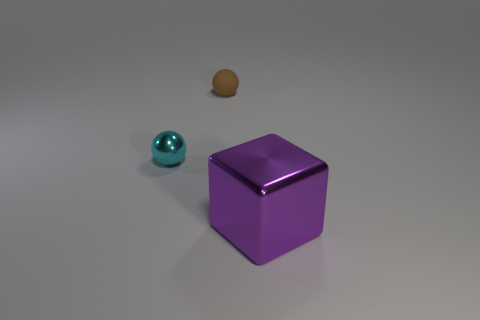Add 1 blocks. How many objects exist? 4 Subtract all blocks. How many objects are left? 2 Add 1 small metal objects. How many small metal objects are left? 2 Add 1 big yellow rubber objects. How many big yellow rubber objects exist? 1 Subtract 0 gray balls. How many objects are left? 3 Subtract all blue rubber cubes. Subtract all large purple blocks. How many objects are left? 2 